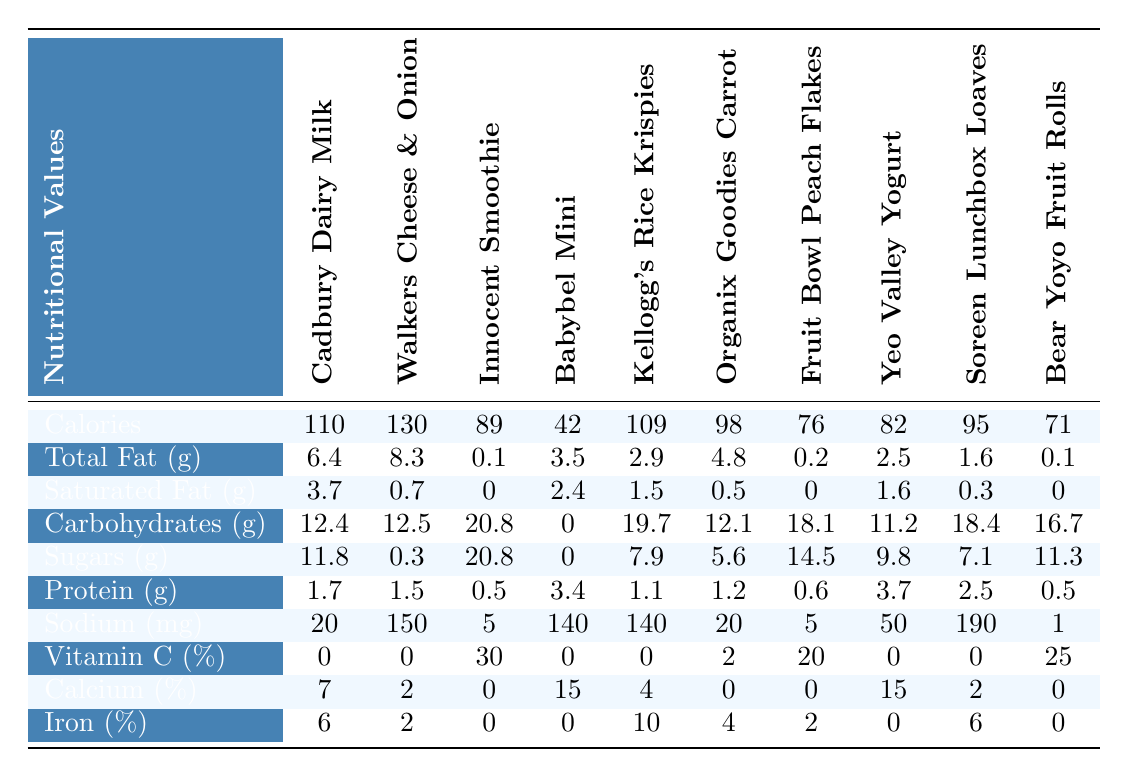What is the highest calorie snack in the table? The highest calorie snack is the Walkers Cheese & Onion Crisps with 130 calories, as indicated in the calories per serving row.
Answer: Walkers Cheese & Onion Crisps How many grams of sugar are in the Innocent Smoothie for Kids? The Innocent Smoothie for Kids contains 20.8 grams of sugar, as shown in the sugars per serving row.
Answer: 20.8 grams Which snack has the least amount of protein? The Bear Yoyo Strawberry Fruit Rolls and the Innocent Smoothie for Kids each have the least amount of protein at 0.5 grams, as listed in the protein per serving row.
Answer: Bear Yoyo Strawberry Fruit Rolls and Innocent Smoothie for Kids What is the total fat content difference between Cadbury Dairy Milk and Babybel Mini? The total fat in Cadbury Dairy Milk is 6.4 grams and in Babybel Mini is 3.5 grams. The difference is 6.4 - 3.5 = 2.9 grams.
Answer: 2.9 grams Does the Yeo Valley Little Yeos Strawberry Yogurt provide any Vitamin C? Yes, the Yeo Valley Little Yeos Strawberry Yogurt provides 0% of the daily value for Vitamin C, as indicated in the Vitamin C percent daily value row.
Answer: Yes Which snack has the highest percentage of calcium? The Babybel Mini and Yeo Valley Little Yeos Strawberry Yogurt both provide 15% of the daily value of calcium, which is higher than any other snack in the table.
Answer: Babybel Mini and Yeo Valley Little Yeos Strawberry Yogurt What is the average sodium content of all snacks listed in the table? Summing up the sodium values: 20 + 150 + 5 + 140 + 140 + 20 + 5 + 50 + 190 + 1 = 721 mg, then dividing by 10 snacks gives an average sodium content of 72.1 mg.
Answer: 72.1 mg Is there any snack that provides 0% iron daily value? Yes, both Innocent Smoothie for Kids and Yeo Valley Little Yeos Strawberry Yogurt provide 0% daily value of iron, as shown in the iron percent daily value row.
Answer: Yes Which snack has a higher content of saturated fat: Walkers Cheese & Onion Crisps or Kellogg's Rice Krispies Squares? Walkers Cheese & Onion Crisps have 0.7 grams of saturated fat, whereas Kellogg's Rice Krispies Squares have 1.5 grams. Thus, Kellogg's Rice Krispies Squares contains more saturated fat.
Answer: Kellogg's Rice Krispies Squares How much total carbohydrate content does Bear Yoyo Strawberry Fruit Rolls have compared to Soreen Lunchbox Loaves? Bear Yoyo Strawberry Fruit Rolls has 16.7 grams and Soreen Lunchbox Loaves has 18.4 grams of carbohydrates. The difference is 18.4 - 16.7 = 1.7 grams, making Soreen Lunchbox Loaves higher.
Answer: 1.7 grams 